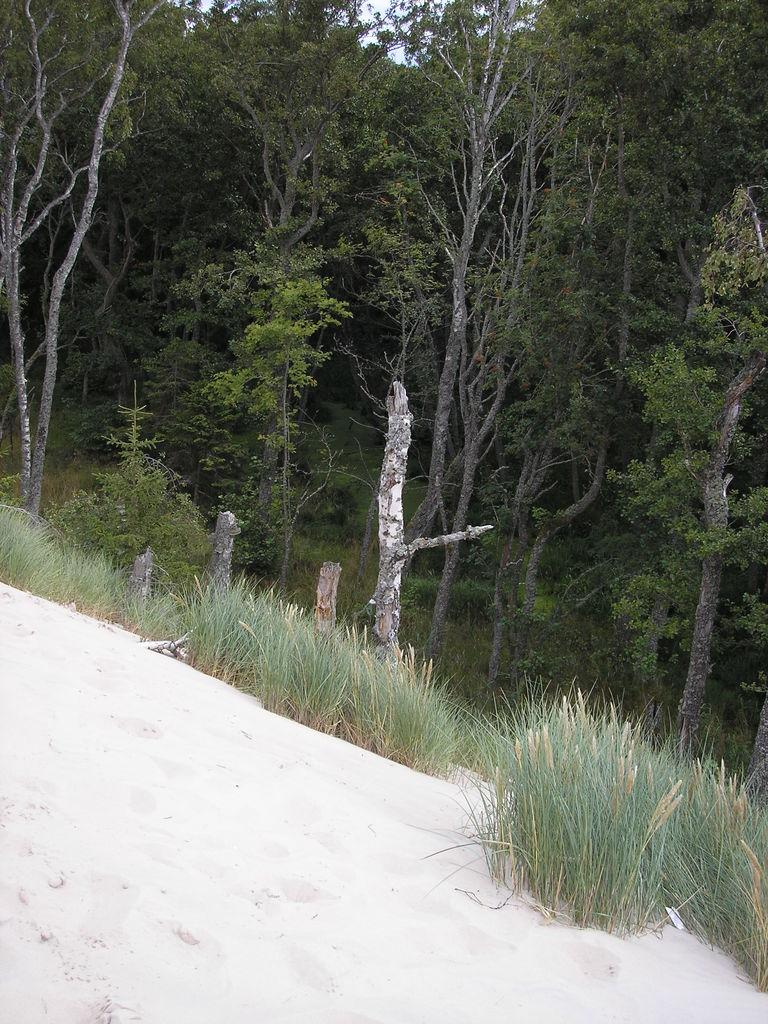What type of natural environment is depicted in the image? The image features many trees and plants, suggesting a natural setting. What type of ground surface is visible in the image? There is sand visible at the bottom of the image. What part of the natural environment is visible in the image? The sky is visible in the image. What trail can be seen leading to the history museum in the image? There is no trail or history museum present in the image. What afterthought is depicted in the image? There is no afterthought depicted in the image; it features trees, plants, sand, and sky. 